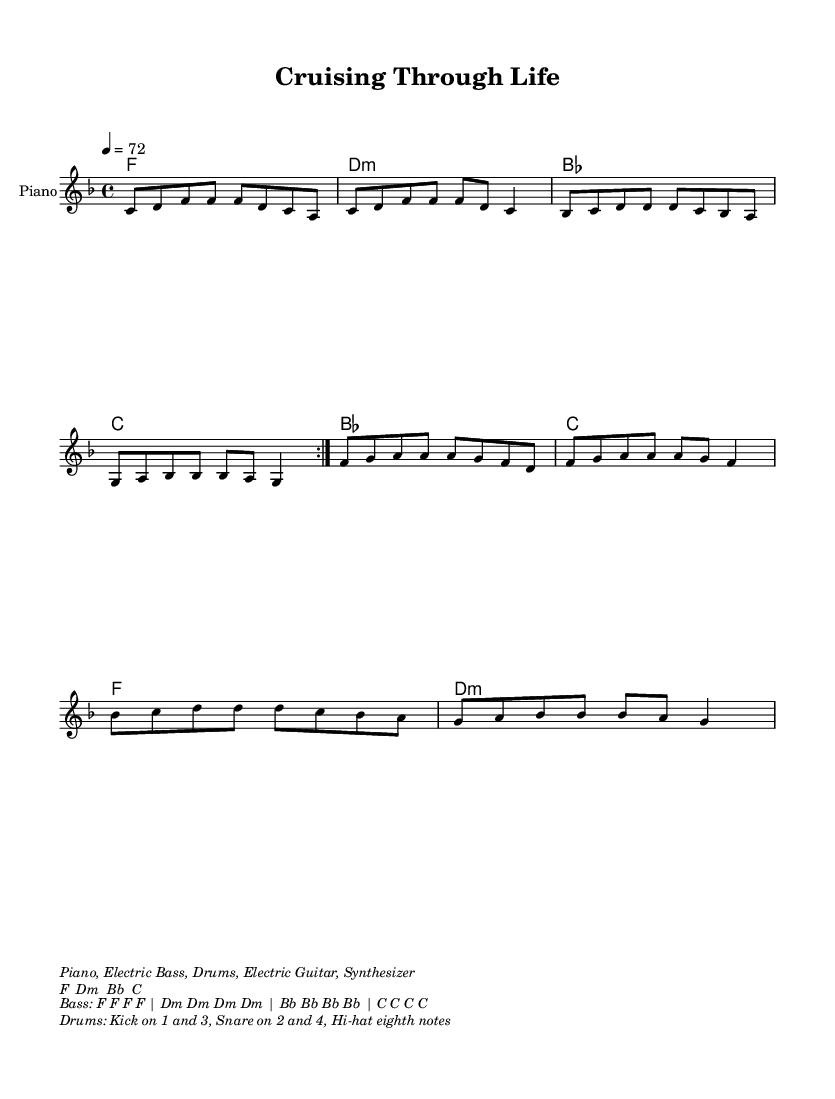What is the key signature of this music? The key signature is F major, which has one flat (B flat). This can be determined by looking at the key signature symbol placed at the beginning of the staff.
Answer: F major What is the time signature of this piece? The time signature is 4/4, as indicated at the beginning of the score. This means there are four beats in each measure and the quarter note receives one beat.
Answer: 4/4 What is the tempo marking of the piece? The tempo marking is quarter note = 72. This indicates the speed of the music, specifying the number of quarter note beats that occur in one minute.
Answer: 72 How many measures are in the melody before the first repeat? There are 8 measures in the melody before the first repeat marking. Counting the measures helps identify how long the phrase is before it repeats.
Answer: 8 What chord is played on the first measure? The chord in the first measure is F major. This is shown in the chord names written above the staff at the beginning of the piece.
Answer: F How many times is the chorus played in the music? The chorus is played 2 times based on the repeat markings indicated in both the melody and the chord names. The repeat symbol indicates that the section should be played again.
Answer: 2 What are the instruments indicated for this piece? The instruments indicated are Piano, Electric Bass, Drums, Electric Guitar, and Synthesizer. This information is contained in the markup at the bottom of the score, detailing the instrumentation used in the arrangement.
Answer: Piano, Electric Bass, Drums, Electric Guitar, Synthesizer 